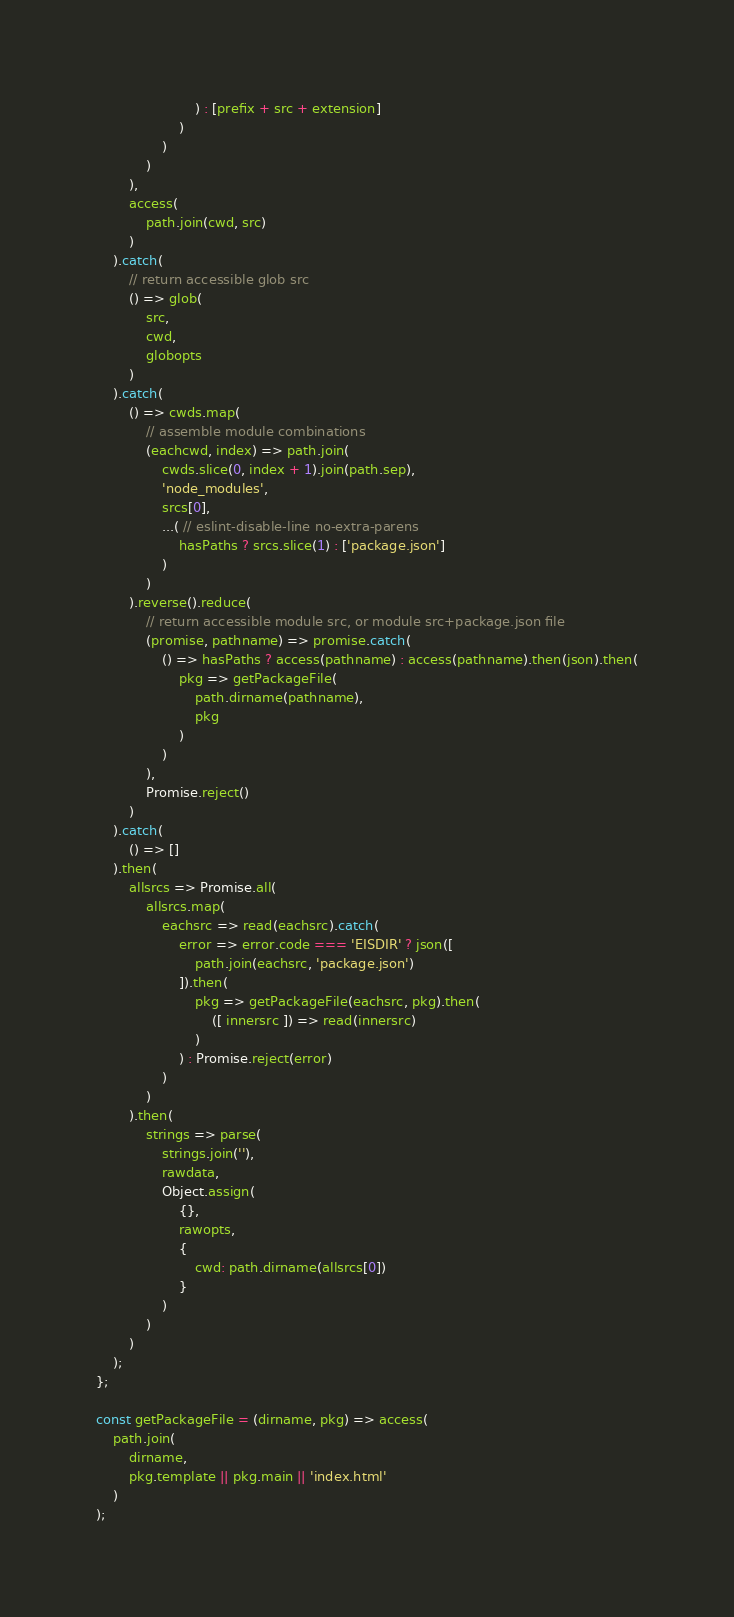<code> <loc_0><loc_0><loc_500><loc_500><_JavaScript_>						) : [prefix + src + extension]
					)
				)
			)
		),
		access(
			path.join(cwd, src)
		)
	).catch(
		// return accessible glob src
		() => glob(
			src,
			cwd,
			globopts
		)
	).catch(
		() => cwds.map(
			// assemble module combinations
			(eachcwd, index) => path.join(
				cwds.slice(0, index + 1).join(path.sep),
				'node_modules',
				srcs[0],
				...( // eslint-disable-line no-extra-parens
					hasPaths ? srcs.slice(1) : ['package.json']
				)
			)
		).reverse().reduce(
			// return accessible module src, or module src+package.json file
			(promise, pathname) => promise.catch(
				() => hasPaths ? access(pathname) : access(pathname).then(json).then(
					pkg => getPackageFile(
						path.dirname(pathname),
						pkg
					)
				)
			),
			Promise.reject()
		)
	).catch(
		() => []
	).then(
		allsrcs => Promise.all(
			allsrcs.map(
				eachsrc => read(eachsrc).catch(
					error => error.code === 'EISDIR' ? json([
						path.join(eachsrc, 'package.json')
					]).then(
						pkg => getPackageFile(eachsrc, pkg).then(
							([ innersrc ]) => read(innersrc)
						)
					) : Promise.reject(error)
				)
			)
		).then(
			strings => parse(
				strings.join(''),
				rawdata,
				Object.assign(
					{},
					rawopts,
					{
						cwd: path.dirname(allsrcs[0])
					}
				)
			)
		)
	);
};

const getPackageFile = (dirname, pkg) => access(
	path.join(
		dirname,
		pkg.template || pkg.main || 'index.html'
	)
);
</code> 